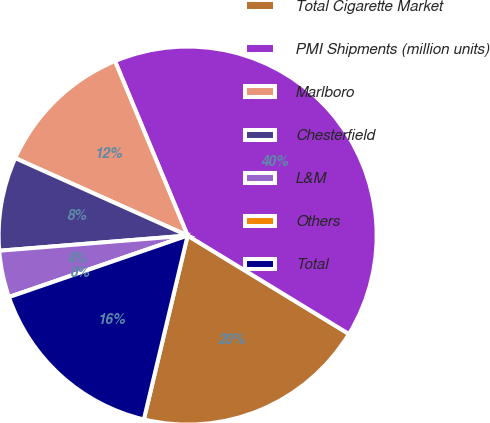Convert chart. <chart><loc_0><loc_0><loc_500><loc_500><pie_chart><fcel>Total Cigarette Market<fcel>PMI Shipments (million units)<fcel>Marlboro<fcel>Chesterfield<fcel>L&M<fcel>Others<fcel>Total<nl><fcel>20.0%<fcel>40.0%<fcel>12.0%<fcel>8.0%<fcel>4.0%<fcel>0.0%<fcel>16.0%<nl></chart> 